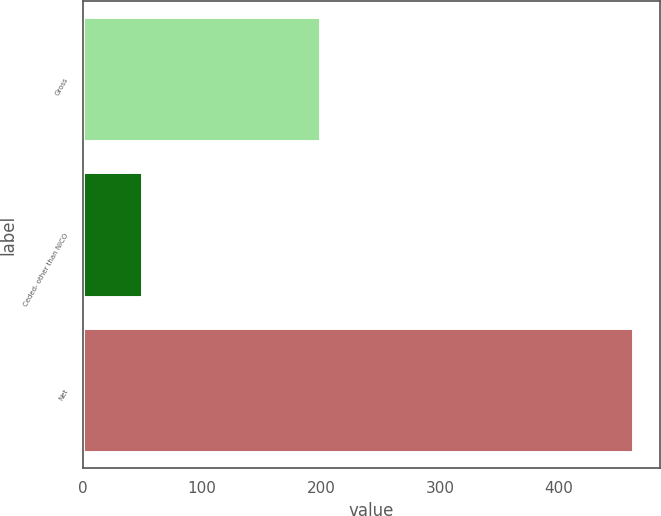Convert chart. <chart><loc_0><loc_0><loc_500><loc_500><bar_chart><fcel>Gross<fcel>Ceded- other than NICO<fcel>Net<nl><fcel>199<fcel>50<fcel>462<nl></chart> 